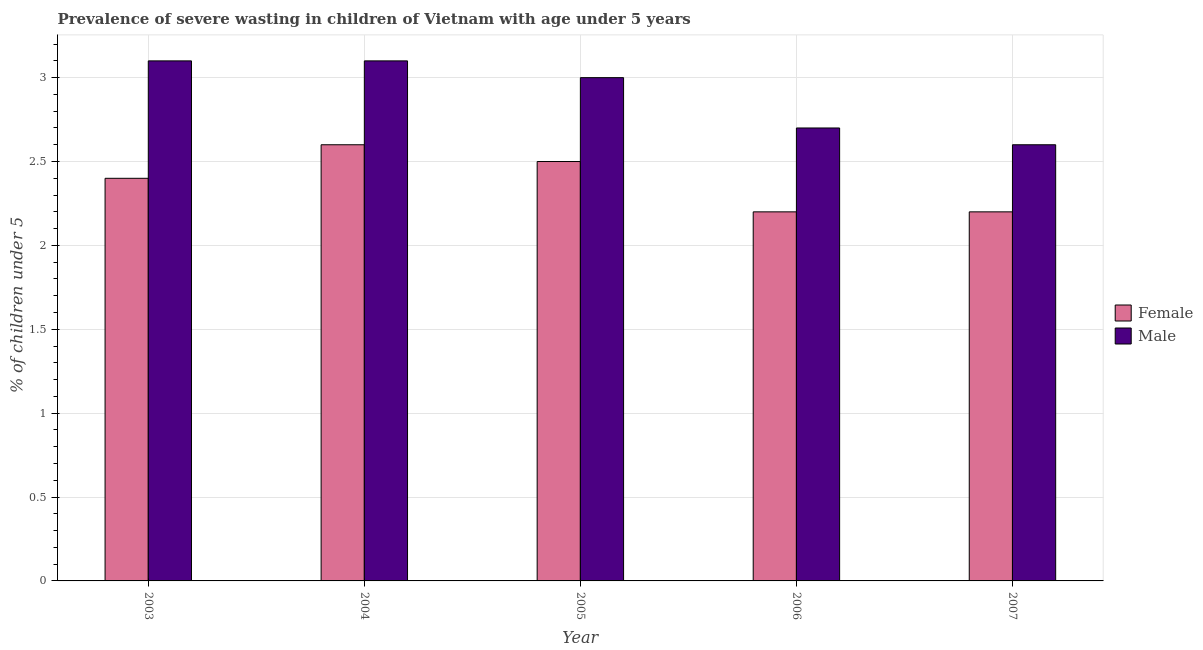How many bars are there on the 3rd tick from the left?
Offer a terse response. 2. How many bars are there on the 3rd tick from the right?
Ensure brevity in your answer.  2. What is the label of the 4th group of bars from the left?
Keep it short and to the point. 2006. In how many cases, is the number of bars for a given year not equal to the number of legend labels?
Your response must be concise. 0. Across all years, what is the maximum percentage of undernourished male children?
Provide a succinct answer. 3.1. Across all years, what is the minimum percentage of undernourished male children?
Your response must be concise. 2.6. What is the total percentage of undernourished female children in the graph?
Keep it short and to the point. 11.9. What is the difference between the percentage of undernourished female children in 2005 and that in 2007?
Your response must be concise. 0.3. What is the difference between the percentage of undernourished male children in 2006 and the percentage of undernourished female children in 2007?
Offer a very short reply. 0.1. What is the average percentage of undernourished male children per year?
Provide a succinct answer. 2.9. In the year 2003, what is the difference between the percentage of undernourished male children and percentage of undernourished female children?
Keep it short and to the point. 0. In how many years, is the percentage of undernourished male children greater than 0.2 %?
Make the answer very short. 5. What is the ratio of the percentage of undernourished female children in 2004 to that in 2005?
Keep it short and to the point. 1.04. Is the percentage of undernourished female children in 2006 less than that in 2007?
Keep it short and to the point. No. What is the difference between the highest and the second highest percentage of undernourished female children?
Give a very brief answer. 0.1. What is the difference between the highest and the lowest percentage of undernourished male children?
Offer a terse response. 0.5. Is the sum of the percentage of undernourished male children in 2005 and 2006 greater than the maximum percentage of undernourished female children across all years?
Keep it short and to the point. Yes. What does the 2nd bar from the right in 2004 represents?
Your answer should be very brief. Female. Are the values on the major ticks of Y-axis written in scientific E-notation?
Provide a succinct answer. No. Does the graph contain any zero values?
Offer a very short reply. No. Does the graph contain grids?
Offer a terse response. Yes. How many legend labels are there?
Offer a terse response. 2. What is the title of the graph?
Your answer should be compact. Prevalence of severe wasting in children of Vietnam with age under 5 years. Does "Females" appear as one of the legend labels in the graph?
Give a very brief answer. No. What is the label or title of the Y-axis?
Ensure brevity in your answer.   % of children under 5. What is the  % of children under 5 in Female in 2003?
Ensure brevity in your answer.  2.4. What is the  % of children under 5 in Male in 2003?
Provide a succinct answer. 3.1. What is the  % of children under 5 of Female in 2004?
Provide a succinct answer. 2.6. What is the  % of children under 5 in Male in 2004?
Provide a short and direct response. 3.1. What is the  % of children under 5 of Male in 2005?
Your answer should be very brief. 3. What is the  % of children under 5 of Female in 2006?
Offer a very short reply. 2.2. What is the  % of children under 5 in Male in 2006?
Provide a succinct answer. 2.7. What is the  % of children under 5 of Female in 2007?
Offer a terse response. 2.2. What is the  % of children under 5 of Male in 2007?
Make the answer very short. 2.6. Across all years, what is the maximum  % of children under 5 of Female?
Offer a very short reply. 2.6. Across all years, what is the maximum  % of children under 5 of Male?
Your answer should be very brief. 3.1. Across all years, what is the minimum  % of children under 5 in Female?
Provide a short and direct response. 2.2. Across all years, what is the minimum  % of children under 5 of Male?
Provide a short and direct response. 2.6. What is the difference between the  % of children under 5 in Male in 2003 and that in 2004?
Keep it short and to the point. 0. What is the difference between the  % of children under 5 of Male in 2003 and that in 2005?
Offer a terse response. 0.1. What is the difference between the  % of children under 5 in Female in 2003 and that in 2006?
Your response must be concise. 0.2. What is the difference between the  % of children under 5 in Female in 2003 and that in 2007?
Offer a terse response. 0.2. What is the difference between the  % of children under 5 in Male in 2003 and that in 2007?
Offer a terse response. 0.5. What is the difference between the  % of children under 5 in Female in 2004 and that in 2005?
Offer a terse response. 0.1. What is the difference between the  % of children under 5 in Female in 2004 and that in 2007?
Your answer should be compact. 0.4. What is the difference between the  % of children under 5 in Male in 2004 and that in 2007?
Provide a succinct answer. 0.5. What is the difference between the  % of children under 5 in Female in 2005 and that in 2006?
Ensure brevity in your answer.  0.3. What is the difference between the  % of children under 5 of Female in 2006 and that in 2007?
Provide a succinct answer. 0. What is the difference between the  % of children under 5 in Female in 2003 and the  % of children under 5 in Male in 2005?
Your answer should be compact. -0.6. What is the difference between the  % of children under 5 in Female in 2003 and the  % of children under 5 in Male in 2007?
Give a very brief answer. -0.2. What is the difference between the  % of children under 5 in Female in 2005 and the  % of children under 5 in Male in 2006?
Provide a short and direct response. -0.2. What is the average  % of children under 5 of Female per year?
Your answer should be very brief. 2.38. What is the average  % of children under 5 of Male per year?
Your response must be concise. 2.9. In the year 2005, what is the difference between the  % of children under 5 of Female and  % of children under 5 of Male?
Give a very brief answer. -0.5. In the year 2007, what is the difference between the  % of children under 5 of Female and  % of children under 5 of Male?
Provide a succinct answer. -0.4. What is the ratio of the  % of children under 5 in Male in 2003 to that in 2006?
Your answer should be very brief. 1.15. What is the ratio of the  % of children under 5 of Female in 2003 to that in 2007?
Give a very brief answer. 1.09. What is the ratio of the  % of children under 5 in Male in 2003 to that in 2007?
Your response must be concise. 1.19. What is the ratio of the  % of children under 5 of Female in 2004 to that in 2006?
Offer a terse response. 1.18. What is the ratio of the  % of children under 5 of Male in 2004 to that in 2006?
Your answer should be very brief. 1.15. What is the ratio of the  % of children under 5 in Female in 2004 to that in 2007?
Make the answer very short. 1.18. What is the ratio of the  % of children under 5 in Male in 2004 to that in 2007?
Your answer should be compact. 1.19. What is the ratio of the  % of children under 5 in Female in 2005 to that in 2006?
Give a very brief answer. 1.14. What is the ratio of the  % of children under 5 in Female in 2005 to that in 2007?
Your answer should be compact. 1.14. What is the ratio of the  % of children under 5 in Male in 2005 to that in 2007?
Provide a succinct answer. 1.15. What is the ratio of the  % of children under 5 in Female in 2006 to that in 2007?
Offer a terse response. 1. What is the difference between the highest and the second highest  % of children under 5 of Male?
Ensure brevity in your answer.  0. What is the difference between the highest and the lowest  % of children under 5 in Female?
Provide a short and direct response. 0.4. 